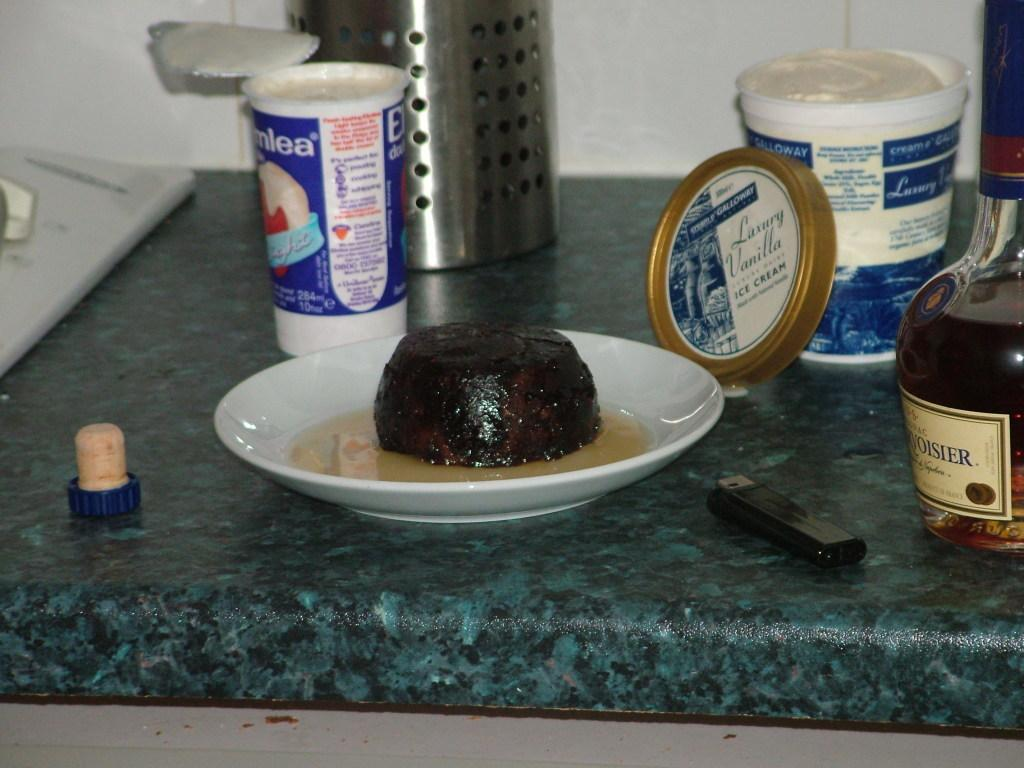<image>
Relay a brief, clear account of the picture shown. A container of Luxury Vanilla ice cream is open next to a plate of Christmas  pudding. 